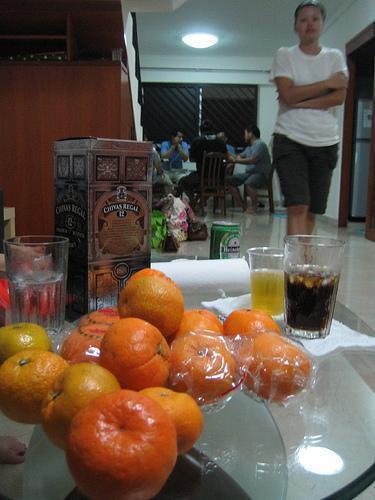How many glasses are on the table?
Give a very brief answer. 3. How many oranges are still wrapped?
Give a very brief answer. 4. How many people are wearing blue shirts?
Give a very brief answer. 2. How many people are standing?
Give a very brief answer. 1. How many oranges are there?
Give a very brief answer. 13. How many cans are on the table?
Give a very brief answer. 1. How many boxes are on the table?
Give a very brief answer. 1. How many people are sitting at the table?
Give a very brief answer. 5. How many ceiling lights are there?
Give a very brief answer. 1. How many clear glasses are there?
Give a very brief answer. 3. How many people are visible?
Give a very brief answer. 2. How many oranges are there?
Give a very brief answer. 7. How many cups are in the photo?
Give a very brief answer. 3. How many freight cars are there?
Give a very brief answer. 0. 